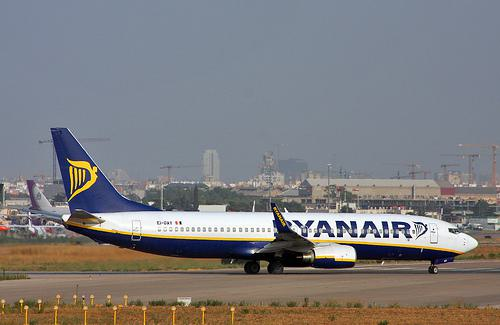Describe the surrounding environment of the airport. The airport appears to be situated near a city, as indicated by the buildings visible in the distance. The weather is clear, which suggests good flying conditions. The ground support, such as lighting poles and signs, around the taxiway shows that the airport is well-equipped for commercial flights. 